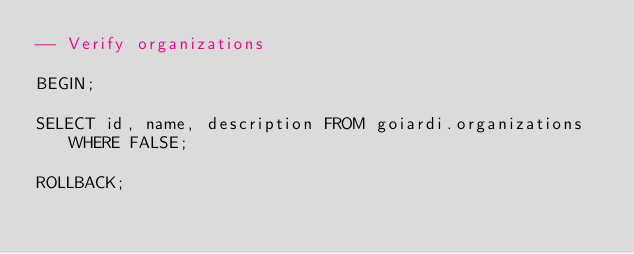<code> <loc_0><loc_0><loc_500><loc_500><_SQL_>-- Verify organizations

BEGIN;

SELECT id, name, description FROM goiardi.organizations WHERE FALSE;

ROLLBACK;
</code> 